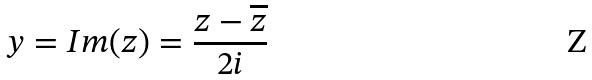Convert formula to latex. <formula><loc_0><loc_0><loc_500><loc_500>y = I m ( z ) = \frac { z - \overline { z } } { 2 i }</formula> 